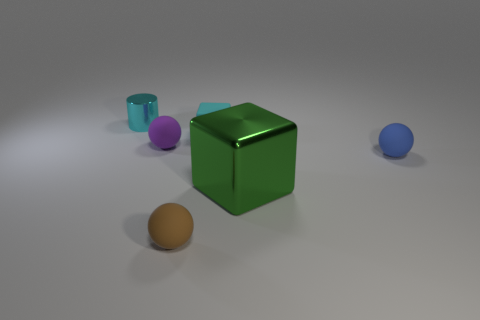Do the large green metal object and the purple thing have the same shape? No, they do not. The large green object appears to be a cube, characterized by its six equal squares, sharp edges, and vertices. On the other hand, the purple object has a spherical shape, evident from its smooth, round surface without edges or vertices. 